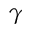Convert formula to latex. <formula><loc_0><loc_0><loc_500><loc_500>\gamma</formula> 